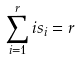<formula> <loc_0><loc_0><loc_500><loc_500>\sum _ { i = 1 } ^ { r } i s _ { i } = r</formula> 